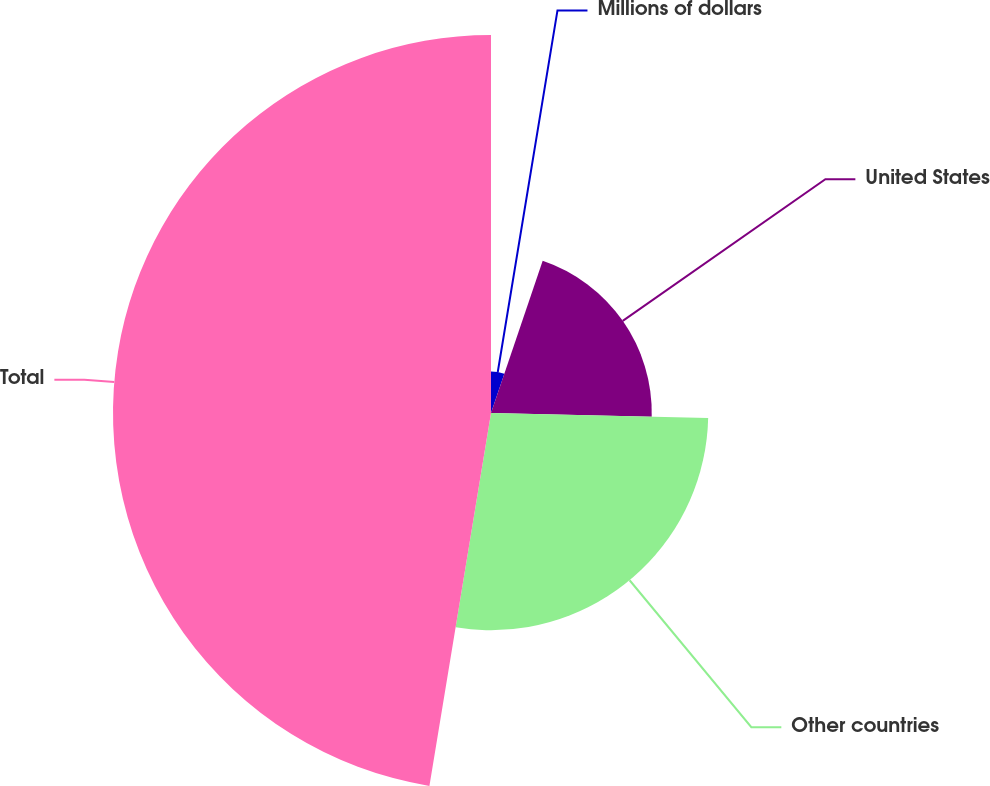Convert chart. <chart><loc_0><loc_0><loc_500><loc_500><pie_chart><fcel>Millions of dollars<fcel>United States<fcel>Other countries<fcel>Total<nl><fcel>5.21%<fcel>20.16%<fcel>27.24%<fcel>47.4%<nl></chart> 